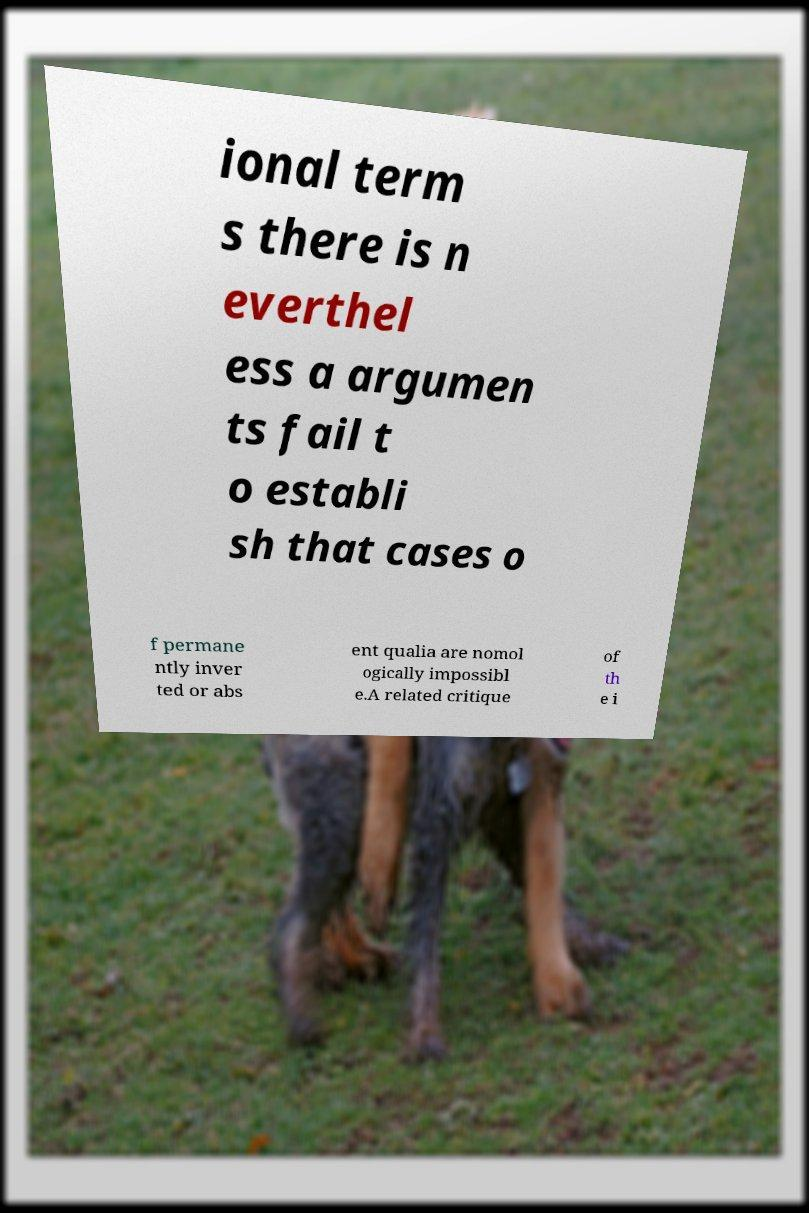For documentation purposes, I need the text within this image transcribed. Could you provide that? ional term s there is n everthel ess a argumen ts fail t o establi sh that cases o f permane ntly inver ted or abs ent qualia are nomol ogically impossibl e.A related critique of th e i 